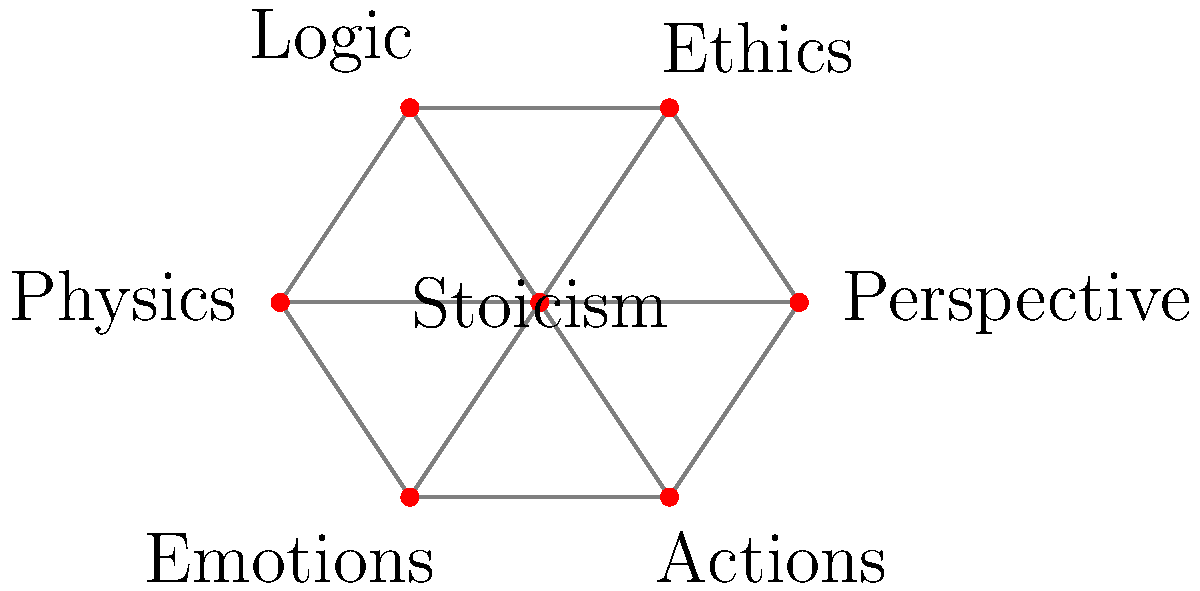In the mind map representing the influence of Stoic philosophy on different aspects of life, what is the minimum number of connections that need to be removed to disconnect "Stoicism" from "Perspective"? To solve this problem, we need to apply the concept of edge connectivity in graph theory. The edge connectivity is the minimum number of edges that need to be removed to disconnect two vertices in a graph.

Let's approach this step-by-step:

1. Observe that "Stoicism" is at the center of the mind map, connected to all other vertices.

2. There are two types of paths from "Stoicism" to "Perspective":
   a) Direct path: Stoicism - Perspective
   b) Indirect paths: through other vertices

3. To disconnect "Stoicism" from "Perspective", we need to remove:
   - The direct edge between them
   - All indirect paths

4. The indirect paths are:
   - Stoicism - Ethics - Perspective
   - Stoicism - Logic - Perspective
   - Stoicism - Physics - Perspective
   - Stoicism - Emotions - Perspective
   - Stoicism - Actions - Perspective

5. To break all these paths, we need to remove at least one edge from each path.

6. The most efficient way to do this is to remove all edges connected to "Stoicism", which are 6 in total.

Therefore, the minimum number of connections that need to be removed to disconnect "Stoicism" from "Perspective" is 6.
Answer: 6 